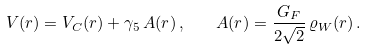<formula> <loc_0><loc_0><loc_500><loc_500>V ( r ) = V _ { C } ( r ) + \gamma _ { 5 } \, A ( r ) \, , \quad A ( r ) = \frac { G _ { F } } { 2 \sqrt { 2 } } \, \varrho _ { W } ( r ) \, .</formula> 